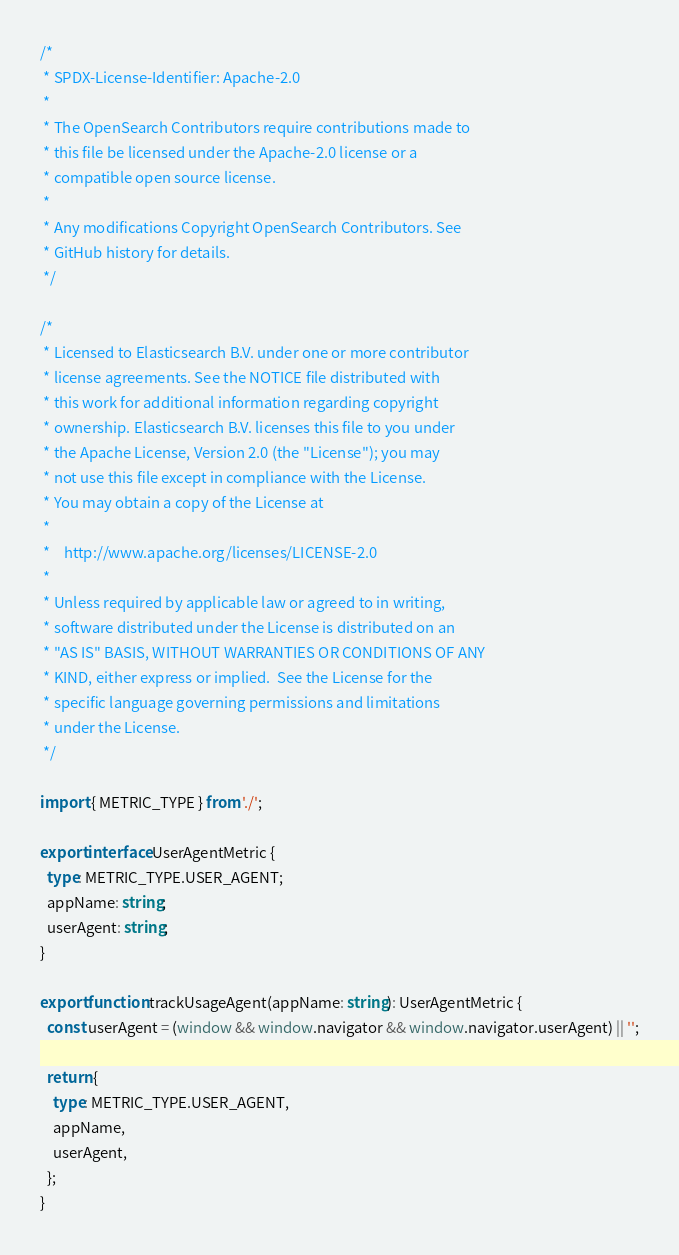<code> <loc_0><loc_0><loc_500><loc_500><_TypeScript_>/*
 * SPDX-License-Identifier: Apache-2.0
 *
 * The OpenSearch Contributors require contributions made to
 * this file be licensed under the Apache-2.0 license or a
 * compatible open source license.
 *
 * Any modifications Copyright OpenSearch Contributors. See
 * GitHub history for details.
 */

/*
 * Licensed to Elasticsearch B.V. under one or more contributor
 * license agreements. See the NOTICE file distributed with
 * this work for additional information regarding copyright
 * ownership. Elasticsearch B.V. licenses this file to you under
 * the Apache License, Version 2.0 (the "License"); you may
 * not use this file except in compliance with the License.
 * You may obtain a copy of the License at
 *
 *    http://www.apache.org/licenses/LICENSE-2.0
 *
 * Unless required by applicable law or agreed to in writing,
 * software distributed under the License is distributed on an
 * "AS IS" BASIS, WITHOUT WARRANTIES OR CONDITIONS OF ANY
 * KIND, either express or implied.  See the License for the
 * specific language governing permissions and limitations
 * under the License.
 */

import { METRIC_TYPE } from './';

export interface UserAgentMetric {
  type: METRIC_TYPE.USER_AGENT;
  appName: string;
  userAgent: string;
}

export function trackUsageAgent(appName: string): UserAgentMetric {
  const userAgent = (window && window.navigator && window.navigator.userAgent) || '';

  return {
    type: METRIC_TYPE.USER_AGENT,
    appName,
    userAgent,
  };
}
</code> 